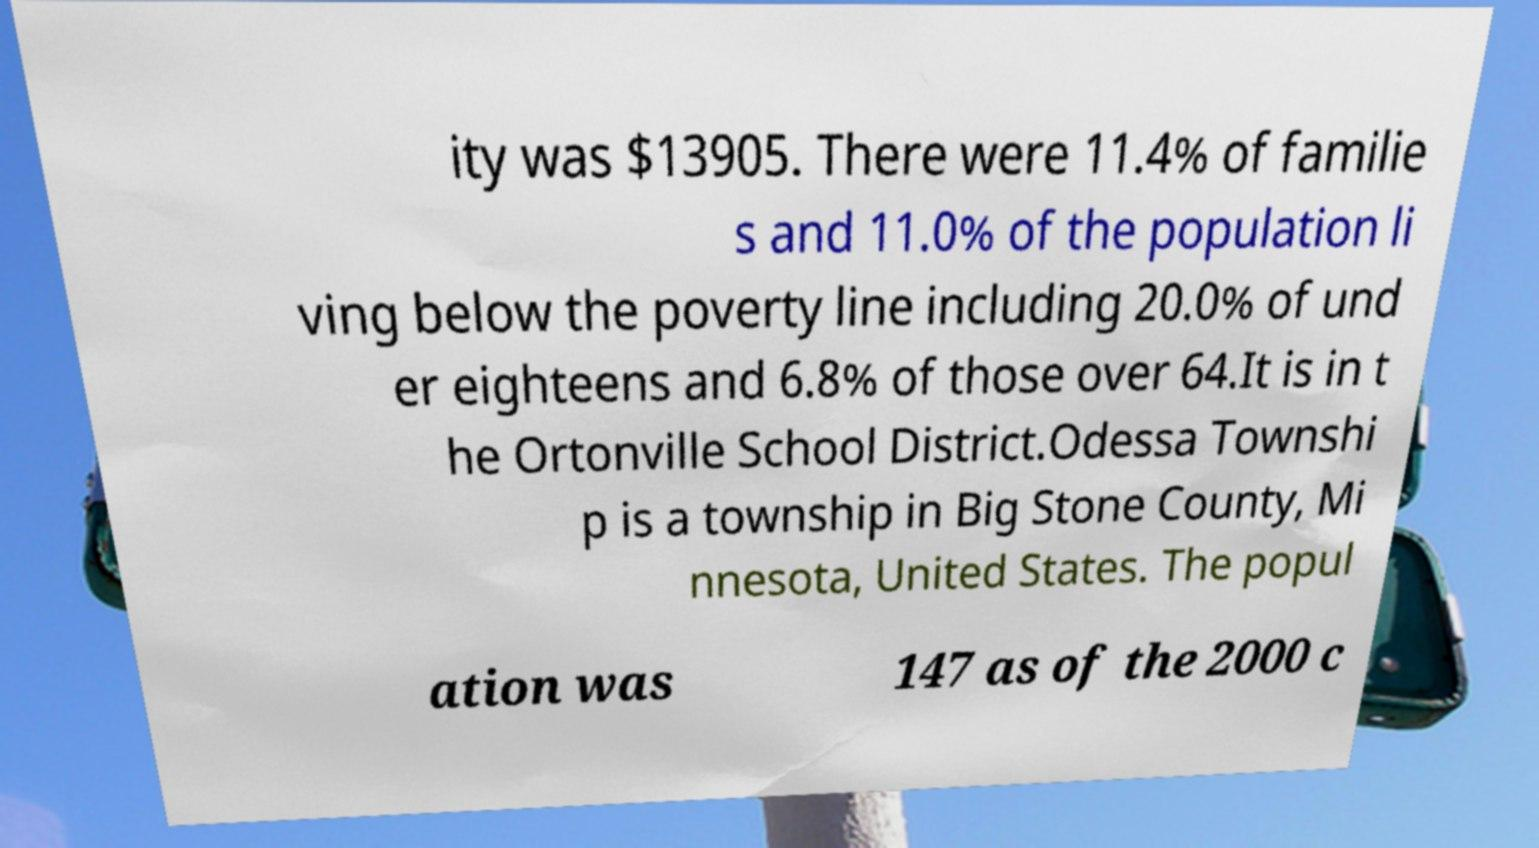Please read and relay the text visible in this image. What does it say? ity was $13905. There were 11.4% of familie s and 11.0% of the population li ving below the poverty line including 20.0% of und er eighteens and 6.8% of those over 64.It is in t he Ortonville School District.Odessa Townshi p is a township in Big Stone County, Mi nnesota, United States. The popul ation was 147 as of the 2000 c 